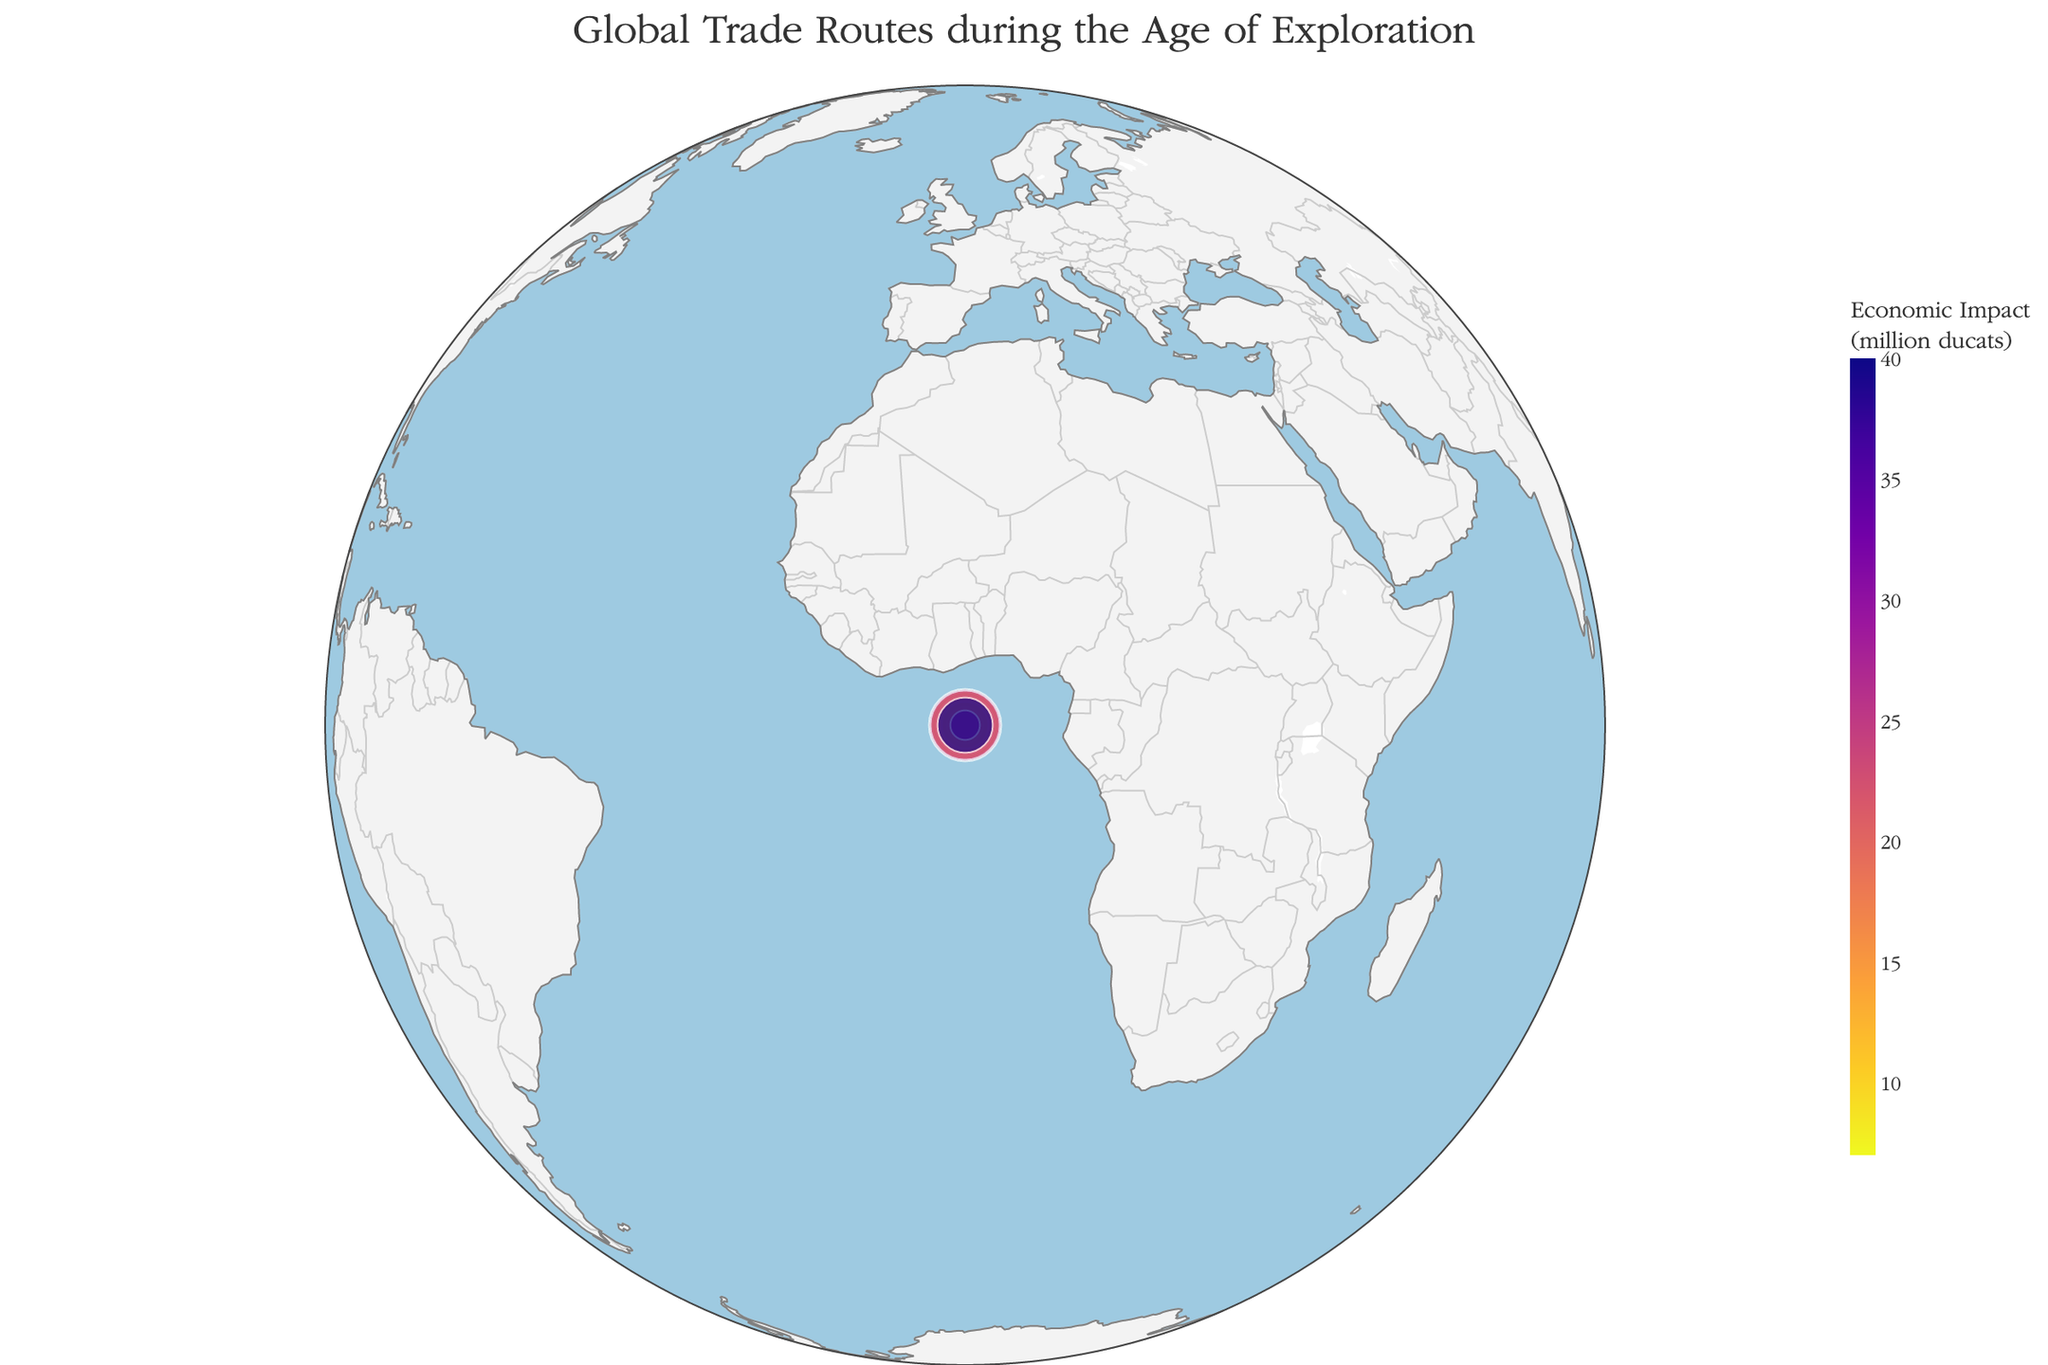How many trade routes are depicted in the figure? Count the total number of unique routes listed in the data table.
Answer: 10 Which trade route has the highest economic impact and what is its value? Identify the route with the largest numerical value under the "Economic Impact (million ducats)" column.
Answer: Spanish Treasure Fleet, 40 million ducats What is the difference in trade volume between the Dutch East India Company and the Portuguese Gold Route? Subtract the trade volume of the Portuguese Gold Route (1000 tons) from the trade volume of the Dutch East India Company (6000 tons).
Answer: 5000 tons Which route has the largest trade volume and what color is it represented with in the plot? Identify the route with the largest trade volume (Dutch East India Company) and describe the color used in the color scale.
Answer: Dutch East India Company, dark color in the Plasma_r color scale Compare the economic impact of the English East India Company and the Spice Route. Which has a greater impact and by how much? Subtract the economic impact of the Spice Route (20 million ducats) from the economic impact of the English East India Company (22 million ducats) to see which is larger and by how much.
Answer: English East India Company, 2 million ducats What is the title of the figure? Look at the title displayed at the top of the figure.
Answer: Global Trade Routes during the Age of Exploration Which trade routes start from Lisbon? Identify and list the routes that have Lisbon as their starting point (Carreira da India and Portuguese Gold Route).
Answer: Carreira da India, Portuguese Gold Route How many trade routes depicted in the figure originate from European cities? Identify the routes starting from the cities Lisbon, Acapulco, Liverpool, Amsterdam, London, and Seville.
Answer: 7 What is the average economic impact of all the trade routes combined? Calculate the average by summing all the economic impacts (12+8+15+20+10+7+25+22+30+40=189) and dividing by the number of routes (189/10).
Answer: 18.9 million ducats Which trade route has the smallest trade volume and what are its starting and ending points? Identify the route with the smallest value under "Trade Volume (tons)" and specify its start and end points (Portuguese Gold Route).
Answer: Portuguese Gold Route, Rio de Janeiro to Lisbon 